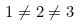Convert formula to latex. <formula><loc_0><loc_0><loc_500><loc_500>1 \neq 2 \neq 3</formula> 